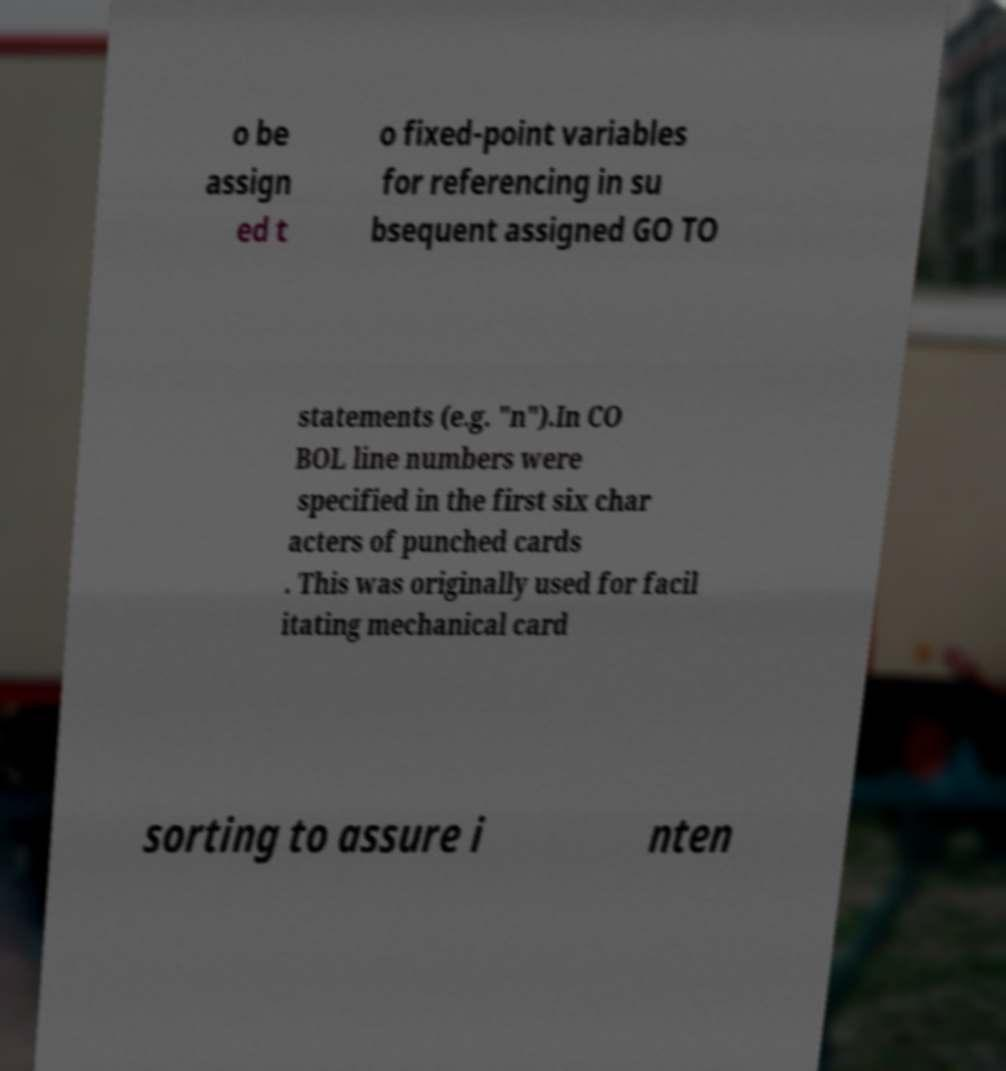Could you assist in decoding the text presented in this image and type it out clearly? o be assign ed t o fixed-point variables for referencing in su bsequent assigned GO TO statements (e.g. "n").In CO BOL line numbers were specified in the first six char acters of punched cards . This was originally used for facil itating mechanical card sorting to assure i nten 